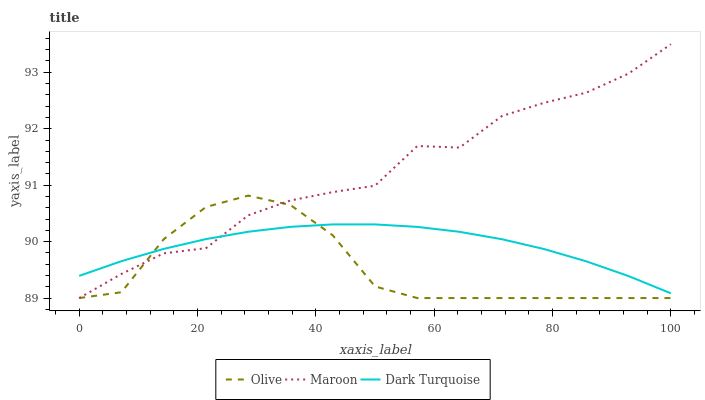Does Olive have the minimum area under the curve?
Answer yes or no. Yes. Does Maroon have the maximum area under the curve?
Answer yes or no. Yes. Does Dark Turquoise have the minimum area under the curve?
Answer yes or no. No. Does Dark Turquoise have the maximum area under the curve?
Answer yes or no. No. Is Dark Turquoise the smoothest?
Answer yes or no. Yes. Is Maroon the roughest?
Answer yes or no. Yes. Is Maroon the smoothest?
Answer yes or no. No. Is Dark Turquoise the roughest?
Answer yes or no. No. Does Dark Turquoise have the lowest value?
Answer yes or no. No. Does Maroon have the highest value?
Answer yes or no. Yes. Does Dark Turquoise have the highest value?
Answer yes or no. No. Does Dark Turquoise intersect Olive?
Answer yes or no. Yes. Is Dark Turquoise less than Olive?
Answer yes or no. No. Is Dark Turquoise greater than Olive?
Answer yes or no. No. 